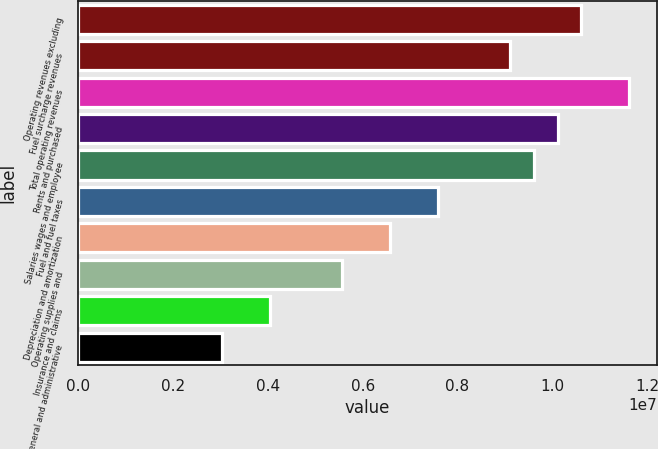<chart> <loc_0><loc_0><loc_500><loc_500><bar_chart><fcel>Operating revenues excluding<fcel>Fuel surcharge revenues<fcel>Total operating revenues<fcel>Rents and purchased<fcel>Salaries wages and employee<fcel>Fuel and fuel taxes<fcel>Depreciation and amortization<fcel>Operating supplies and<fcel>Insurance and claims<fcel>General and administrative<nl><fcel>1.06155e+07<fcel>9.09896e+06<fcel>1.16265e+07<fcel>1.011e+07<fcel>9.60446e+06<fcel>7.58247e+06<fcel>6.57147e+06<fcel>5.56048e+06<fcel>4.04398e+06<fcel>3.03299e+06<nl></chart> 